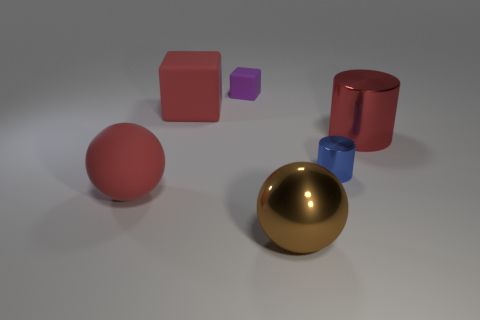There is a cube that is the same color as the big metallic cylinder; what is its material?
Your answer should be compact. Rubber. What number of other objects are there of the same color as the small cube?
Your answer should be compact. 0. There is a blue object; is its shape the same as the small thing that is to the left of the big brown object?
Provide a short and direct response. No. Are there fewer red things that are behind the small metal cylinder than red matte blocks that are to the right of the large brown sphere?
Provide a short and direct response. No. What material is the blue object that is the same shape as the red metal thing?
Ensure brevity in your answer.  Metal. Is there anything else that has the same material as the tiny blue cylinder?
Ensure brevity in your answer.  Yes. Is the large rubber sphere the same color as the big matte block?
Give a very brief answer. Yes. What shape is the purple object that is the same material as the red block?
Your response must be concise. Cube. How many other shiny things have the same shape as the tiny blue object?
Keep it short and to the point. 1. There is a small purple object that is on the right side of the block that is in front of the small purple matte object; what is its shape?
Make the answer very short. Cube. 